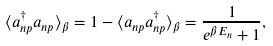Convert formula to latex. <formula><loc_0><loc_0><loc_500><loc_500>\langle a ^ { \dag } _ { n p } a _ { n p } \rangle _ { \beta } = 1 - \langle a _ { n p } a ^ { \dag } _ { n p } \rangle _ { \beta } = \frac { 1 } { e ^ { \beta E _ { n } } + 1 } ,</formula> 